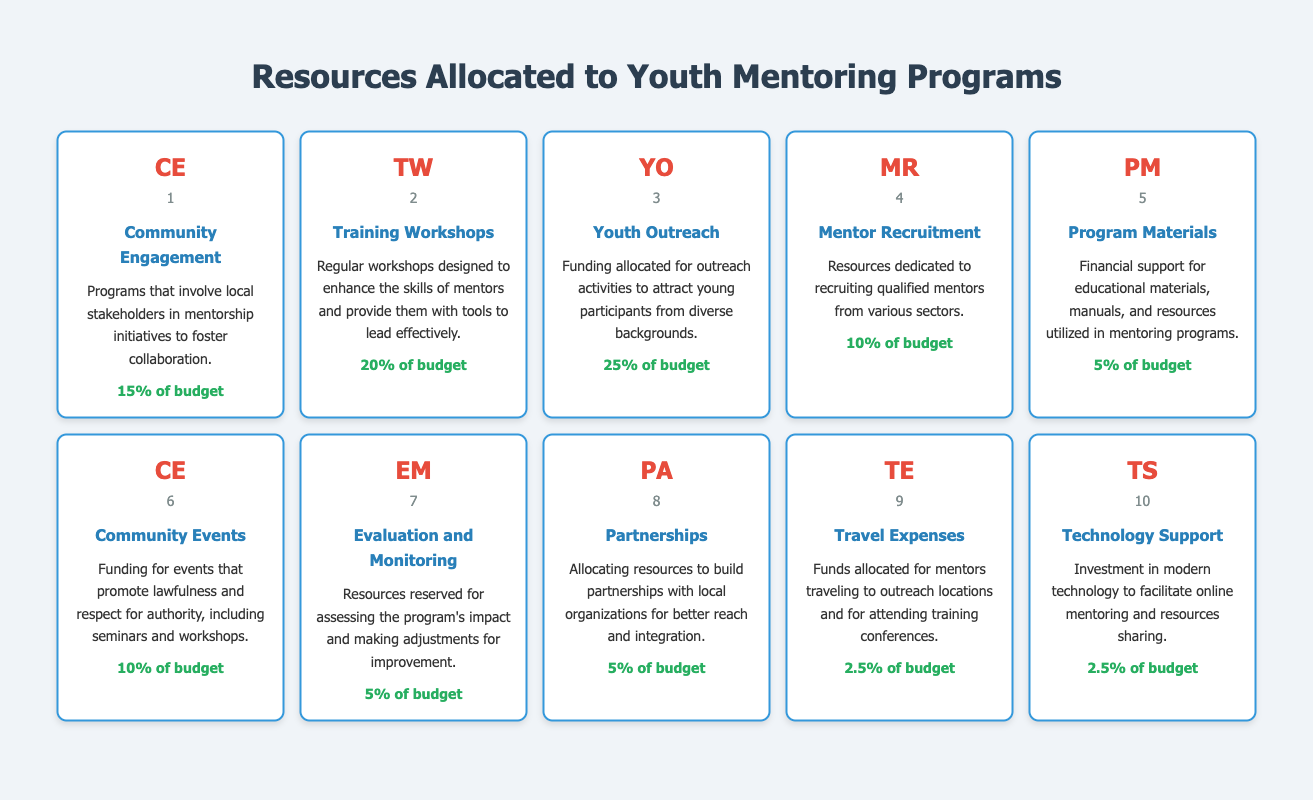What is the resource allocation percentage for Youth Outreach? In the table, locate the row corresponding to Youth Outreach, which indicates its resource allocation. The value listed is 25% of the budget.
Answer: 25% of budget Which program has the highest resource allocation? By comparing the percentages in the resource allocation column, Youth Outreach stands out with the highest allocation of 25%.
Answer: Youth Outreach What is the total percentage allocated to Training Workshops and Community Engagement? First, find the resource allocations for Training Workshops (20%) and Community Engagement (15%). Next, sum them: 20% + 15% = 35%.
Answer: 35% Does Mentor Recruitment have a resource allocation equal to Program Materials? Both Mentor Recruitment and Program Materials show an allocation of 10% and 5%, respectively. Since these amounts are different, the answer is no.
Answer: No Which two programs together account for 35% of the budget? The allocation for Youth Outreach (25%) and Mentor Recruitment (10%) totals up to 35% (25% + 10% = 35%).
Answer: Youth Outreach and Mentor Recruitment What percentage of the budget is spent on Training Workshops compared to the combined amount for Travel Expenses and Technology Support? Training Workshops allocate 20%. Travel Expenses and Technology Support both have 2.5% each, totaling 5%. Comparing 20% to 5% shows that Training Workshops have a significantly higher allocation.
Answer: Yes, Training Workshops is higher What is the resource allocation for Evaluation and Monitoring? Checking the row for Evaluation and Monitoring reveals it is allocated 5% of the budget.
Answer: 5% of budget If we remove the categories with less than 5% resource allocation, how many categories would remain? Categories with less than 5% are Travel Expenses and Technology Support (2.5% each). Removing these two leaves us with 8 categories.
Answer: 8 categories 